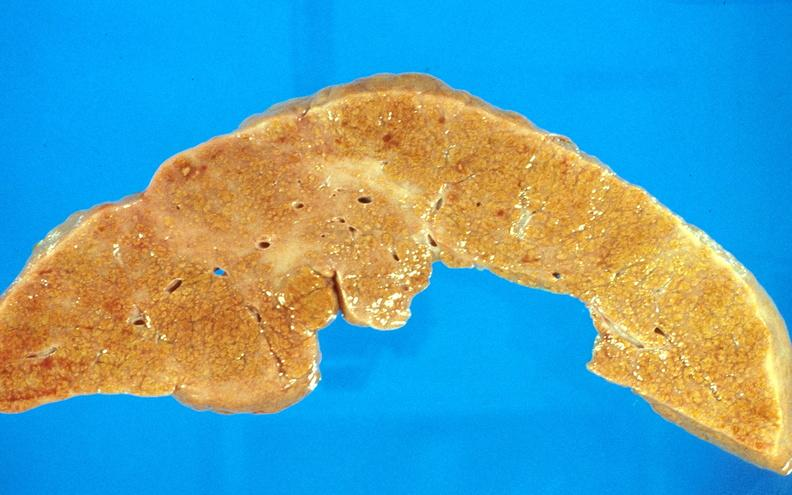s liver present?
Answer the question using a single word or phrase. Yes 